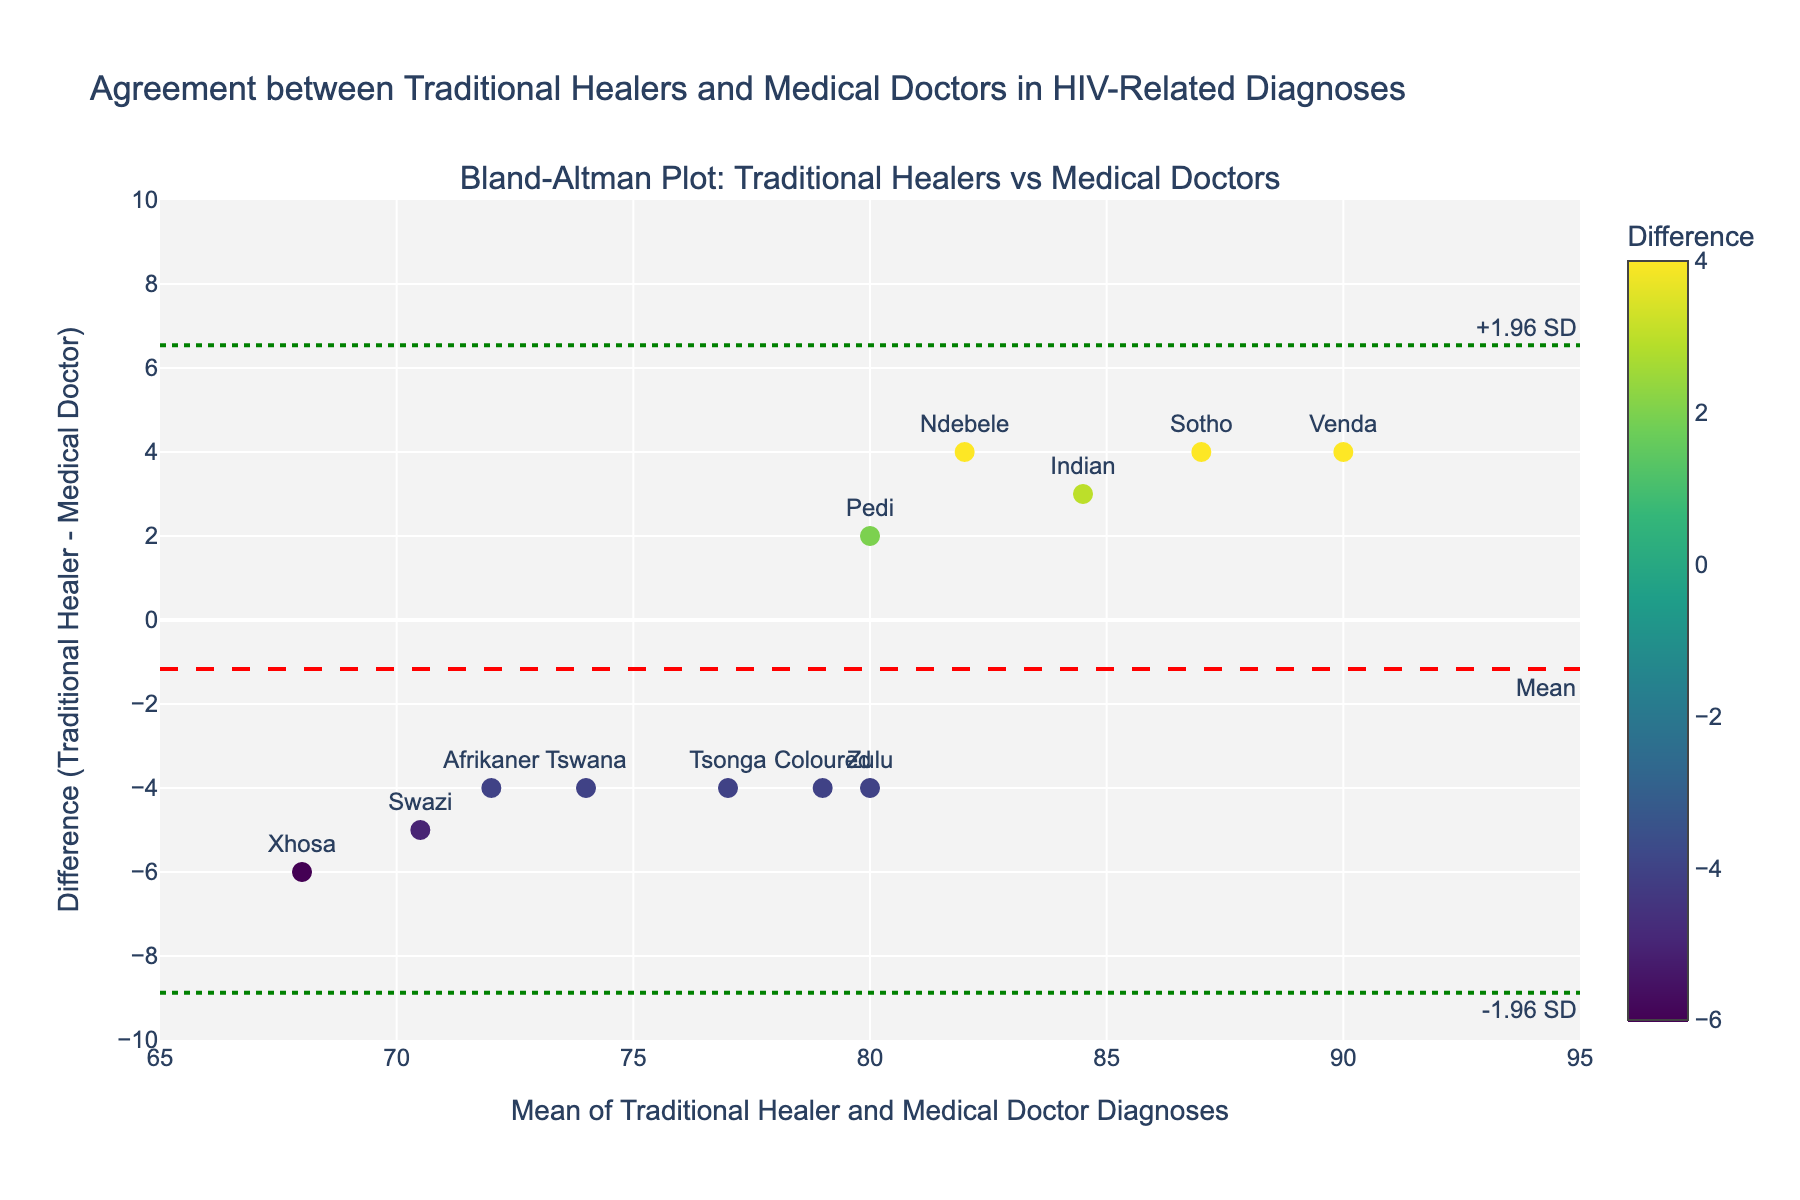What is the title of the figure? Look at the top of the figure where the title is typically located.
Answer: Agreement between Traditional Healers and Medical Doctors in HIV-Related Diagnoses What is the range of the x-axis? Observe the minimum and maximum values on the x-axis.
Answer: 65 to 95 How many data points are there in the plot? Count the number of individual points on the scatter plot.
Answer: 12 Which ethnic group has the highest difference between traditional healers' and medical doctors' diagnoses? Identify the point with the highest y-value and check its associated label.
Answer: Sotho What are the limits of agreement on the plot? Look for the horizontal lines labeled with '+1.96 SD' and '-1.96 SD'.
Answer: Approximately 2 and -2 Which ethnic group has a mean diagnosis of 72? Locate the point on the x-axis that corresponds to a mean of 72 and check the label.
Answer: Afrikaner What is the mean difference between the diagnoses of traditional healers and medical doctors? Observe the horizontal line labeled 'Mean' and note its y-value.
Answer: Approximately 0 How does the diagnosis difference for Tswana compare to the overall mean difference? Find the y-value for Tswana and compare it to the value of the 'Mean' line.
Answer: Tswana has a difference of -4, which is less than the mean difference of approximately 0 What is the standard deviation of the differences? Derive from the provided limits of agreement (mean difference ± 1.96 * std) using the y-values of these lines. The upper limit is 2, and the lower limit is -2, indicating (2 - 0) / 1.96.
Answer: Approximately 1.02 